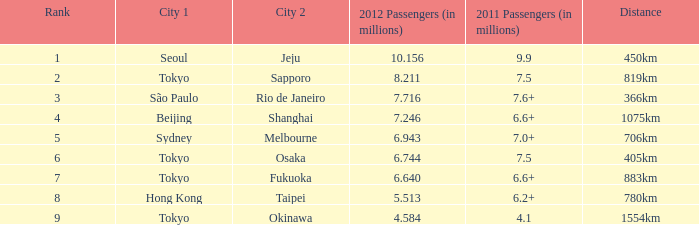How many passengers (in millions) flew through along the route that is 1075km long in 2012? 7.246. 